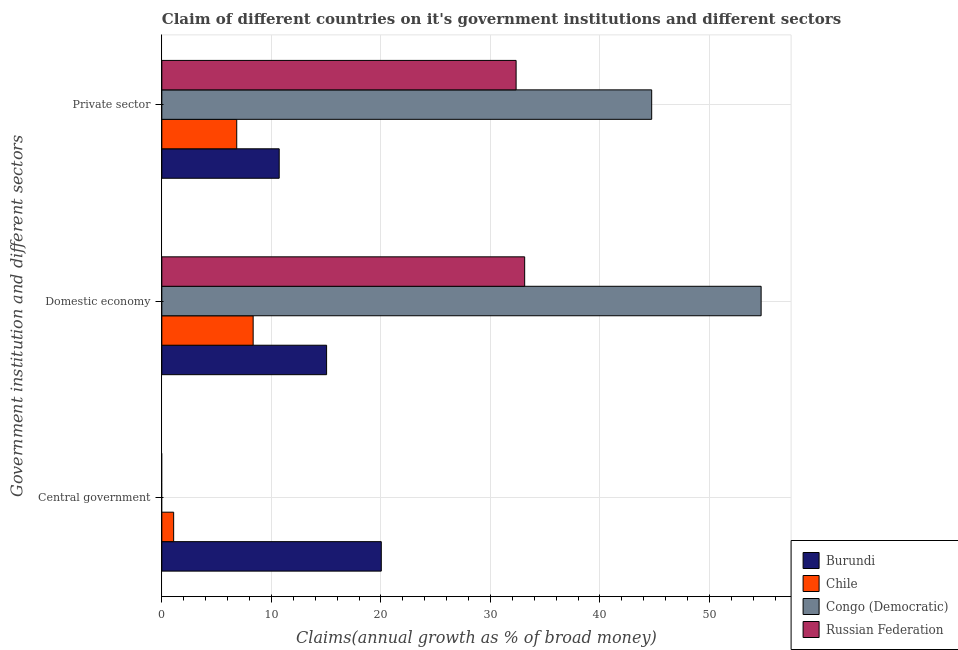Are the number of bars per tick equal to the number of legend labels?
Offer a very short reply. No. What is the label of the 2nd group of bars from the top?
Give a very brief answer. Domestic economy. What is the percentage of claim on the domestic economy in Congo (Democratic)?
Keep it short and to the point. 54.71. Across all countries, what is the maximum percentage of claim on the central government?
Your answer should be compact. 20.04. Across all countries, what is the minimum percentage of claim on the domestic economy?
Offer a very short reply. 8.34. In which country was the percentage of claim on the private sector maximum?
Provide a succinct answer. Congo (Democratic). What is the total percentage of claim on the domestic economy in the graph?
Your response must be concise. 111.22. What is the difference between the percentage of claim on the private sector in Congo (Democratic) and that in Russian Federation?
Your answer should be compact. 12.38. What is the difference between the percentage of claim on the central government in Chile and the percentage of claim on the domestic economy in Russian Federation?
Your response must be concise. -32.05. What is the average percentage of claim on the domestic economy per country?
Provide a short and direct response. 27.8. What is the difference between the percentage of claim on the private sector and percentage of claim on the domestic economy in Russian Federation?
Your answer should be very brief. -0.78. In how many countries, is the percentage of claim on the central government greater than 30 %?
Your response must be concise. 0. What is the ratio of the percentage of claim on the domestic economy in Russian Federation to that in Chile?
Your answer should be very brief. 3.97. Is the difference between the percentage of claim on the domestic economy in Burundi and Chile greater than the difference between the percentage of claim on the private sector in Burundi and Chile?
Your answer should be very brief. Yes. What is the difference between the highest and the second highest percentage of claim on the private sector?
Keep it short and to the point. 12.38. What is the difference between the highest and the lowest percentage of claim on the central government?
Offer a very short reply. 20.04. In how many countries, is the percentage of claim on the domestic economy greater than the average percentage of claim on the domestic economy taken over all countries?
Your answer should be very brief. 2. Is the sum of the percentage of claim on the private sector in Congo (Democratic) and Burundi greater than the maximum percentage of claim on the central government across all countries?
Make the answer very short. Yes. How many bars are there?
Your answer should be very brief. 10. Are all the bars in the graph horizontal?
Offer a very short reply. Yes. How many countries are there in the graph?
Provide a short and direct response. 4. Are the values on the major ticks of X-axis written in scientific E-notation?
Keep it short and to the point. No. How many legend labels are there?
Make the answer very short. 4. How are the legend labels stacked?
Your response must be concise. Vertical. What is the title of the graph?
Keep it short and to the point. Claim of different countries on it's government institutions and different sectors. What is the label or title of the X-axis?
Provide a short and direct response. Claims(annual growth as % of broad money). What is the label or title of the Y-axis?
Give a very brief answer. Government institution and different sectors. What is the Claims(annual growth as % of broad money) in Burundi in Central government?
Ensure brevity in your answer.  20.04. What is the Claims(annual growth as % of broad money) in Chile in Central government?
Your answer should be very brief. 1.08. What is the Claims(annual growth as % of broad money) of Congo (Democratic) in Central government?
Ensure brevity in your answer.  0. What is the Claims(annual growth as % of broad money) of Burundi in Domestic economy?
Offer a very short reply. 15.04. What is the Claims(annual growth as % of broad money) in Chile in Domestic economy?
Offer a very short reply. 8.34. What is the Claims(annual growth as % of broad money) of Congo (Democratic) in Domestic economy?
Make the answer very short. 54.71. What is the Claims(annual growth as % of broad money) of Russian Federation in Domestic economy?
Provide a succinct answer. 33.13. What is the Claims(annual growth as % of broad money) in Burundi in Private sector?
Provide a short and direct response. 10.72. What is the Claims(annual growth as % of broad money) of Chile in Private sector?
Your answer should be compact. 6.84. What is the Claims(annual growth as % of broad money) in Congo (Democratic) in Private sector?
Your answer should be very brief. 44.72. What is the Claims(annual growth as % of broad money) of Russian Federation in Private sector?
Your response must be concise. 32.34. Across all Government institution and different sectors, what is the maximum Claims(annual growth as % of broad money) in Burundi?
Give a very brief answer. 20.04. Across all Government institution and different sectors, what is the maximum Claims(annual growth as % of broad money) in Chile?
Make the answer very short. 8.34. Across all Government institution and different sectors, what is the maximum Claims(annual growth as % of broad money) in Congo (Democratic)?
Keep it short and to the point. 54.71. Across all Government institution and different sectors, what is the maximum Claims(annual growth as % of broad money) in Russian Federation?
Keep it short and to the point. 33.13. Across all Government institution and different sectors, what is the minimum Claims(annual growth as % of broad money) of Burundi?
Give a very brief answer. 10.72. Across all Government institution and different sectors, what is the minimum Claims(annual growth as % of broad money) of Chile?
Your answer should be very brief. 1.08. Across all Government institution and different sectors, what is the minimum Claims(annual growth as % of broad money) in Congo (Democratic)?
Offer a terse response. 0. What is the total Claims(annual growth as % of broad money) of Burundi in the graph?
Make the answer very short. 45.79. What is the total Claims(annual growth as % of broad money) of Chile in the graph?
Offer a terse response. 16.26. What is the total Claims(annual growth as % of broad money) of Congo (Democratic) in the graph?
Your response must be concise. 99.43. What is the total Claims(annual growth as % of broad money) in Russian Federation in the graph?
Ensure brevity in your answer.  65.47. What is the difference between the Claims(annual growth as % of broad money) in Burundi in Central government and that in Domestic economy?
Make the answer very short. 4.99. What is the difference between the Claims(annual growth as % of broad money) of Chile in Central government and that in Domestic economy?
Your answer should be very brief. -7.26. What is the difference between the Claims(annual growth as % of broad money) in Burundi in Central government and that in Private sector?
Make the answer very short. 9.32. What is the difference between the Claims(annual growth as % of broad money) of Chile in Central government and that in Private sector?
Provide a succinct answer. -5.76. What is the difference between the Claims(annual growth as % of broad money) of Burundi in Domestic economy and that in Private sector?
Offer a very short reply. 4.33. What is the difference between the Claims(annual growth as % of broad money) in Chile in Domestic economy and that in Private sector?
Your answer should be compact. 1.5. What is the difference between the Claims(annual growth as % of broad money) of Congo (Democratic) in Domestic economy and that in Private sector?
Your response must be concise. 9.99. What is the difference between the Claims(annual growth as % of broad money) in Russian Federation in Domestic economy and that in Private sector?
Keep it short and to the point. 0.78. What is the difference between the Claims(annual growth as % of broad money) of Burundi in Central government and the Claims(annual growth as % of broad money) of Chile in Domestic economy?
Your answer should be very brief. 11.7. What is the difference between the Claims(annual growth as % of broad money) of Burundi in Central government and the Claims(annual growth as % of broad money) of Congo (Democratic) in Domestic economy?
Ensure brevity in your answer.  -34.68. What is the difference between the Claims(annual growth as % of broad money) of Burundi in Central government and the Claims(annual growth as % of broad money) of Russian Federation in Domestic economy?
Your answer should be very brief. -13.09. What is the difference between the Claims(annual growth as % of broad money) in Chile in Central government and the Claims(annual growth as % of broad money) in Congo (Democratic) in Domestic economy?
Give a very brief answer. -53.63. What is the difference between the Claims(annual growth as % of broad money) of Chile in Central government and the Claims(annual growth as % of broad money) of Russian Federation in Domestic economy?
Keep it short and to the point. -32.05. What is the difference between the Claims(annual growth as % of broad money) of Burundi in Central government and the Claims(annual growth as % of broad money) of Chile in Private sector?
Provide a short and direct response. 13.2. What is the difference between the Claims(annual growth as % of broad money) of Burundi in Central government and the Claims(annual growth as % of broad money) of Congo (Democratic) in Private sector?
Provide a succinct answer. -24.69. What is the difference between the Claims(annual growth as % of broad money) in Burundi in Central government and the Claims(annual growth as % of broad money) in Russian Federation in Private sector?
Your answer should be very brief. -12.31. What is the difference between the Claims(annual growth as % of broad money) in Chile in Central government and the Claims(annual growth as % of broad money) in Congo (Democratic) in Private sector?
Make the answer very short. -43.64. What is the difference between the Claims(annual growth as % of broad money) of Chile in Central government and the Claims(annual growth as % of broad money) of Russian Federation in Private sector?
Provide a short and direct response. -31.26. What is the difference between the Claims(annual growth as % of broad money) of Burundi in Domestic economy and the Claims(annual growth as % of broad money) of Chile in Private sector?
Your response must be concise. 8.2. What is the difference between the Claims(annual growth as % of broad money) in Burundi in Domestic economy and the Claims(annual growth as % of broad money) in Congo (Democratic) in Private sector?
Offer a terse response. -29.68. What is the difference between the Claims(annual growth as % of broad money) of Burundi in Domestic economy and the Claims(annual growth as % of broad money) of Russian Federation in Private sector?
Keep it short and to the point. -17.3. What is the difference between the Claims(annual growth as % of broad money) in Chile in Domestic economy and the Claims(annual growth as % of broad money) in Congo (Democratic) in Private sector?
Your answer should be very brief. -36.38. What is the difference between the Claims(annual growth as % of broad money) in Chile in Domestic economy and the Claims(annual growth as % of broad money) in Russian Federation in Private sector?
Give a very brief answer. -24.01. What is the difference between the Claims(annual growth as % of broad money) of Congo (Democratic) in Domestic economy and the Claims(annual growth as % of broad money) of Russian Federation in Private sector?
Your response must be concise. 22.37. What is the average Claims(annual growth as % of broad money) of Burundi per Government institution and different sectors?
Your answer should be compact. 15.26. What is the average Claims(annual growth as % of broad money) of Chile per Government institution and different sectors?
Keep it short and to the point. 5.42. What is the average Claims(annual growth as % of broad money) in Congo (Democratic) per Government institution and different sectors?
Offer a terse response. 33.14. What is the average Claims(annual growth as % of broad money) of Russian Federation per Government institution and different sectors?
Ensure brevity in your answer.  21.82. What is the difference between the Claims(annual growth as % of broad money) of Burundi and Claims(annual growth as % of broad money) of Chile in Central government?
Offer a terse response. 18.96. What is the difference between the Claims(annual growth as % of broad money) in Burundi and Claims(annual growth as % of broad money) in Chile in Domestic economy?
Offer a terse response. 6.7. What is the difference between the Claims(annual growth as % of broad money) of Burundi and Claims(annual growth as % of broad money) of Congo (Democratic) in Domestic economy?
Provide a short and direct response. -39.67. What is the difference between the Claims(annual growth as % of broad money) in Burundi and Claims(annual growth as % of broad money) in Russian Federation in Domestic economy?
Offer a very short reply. -18.08. What is the difference between the Claims(annual growth as % of broad money) in Chile and Claims(annual growth as % of broad money) in Congo (Democratic) in Domestic economy?
Give a very brief answer. -46.37. What is the difference between the Claims(annual growth as % of broad money) in Chile and Claims(annual growth as % of broad money) in Russian Federation in Domestic economy?
Keep it short and to the point. -24.79. What is the difference between the Claims(annual growth as % of broad money) in Congo (Democratic) and Claims(annual growth as % of broad money) in Russian Federation in Domestic economy?
Keep it short and to the point. 21.59. What is the difference between the Claims(annual growth as % of broad money) in Burundi and Claims(annual growth as % of broad money) in Chile in Private sector?
Offer a terse response. 3.88. What is the difference between the Claims(annual growth as % of broad money) of Burundi and Claims(annual growth as % of broad money) of Congo (Democratic) in Private sector?
Make the answer very short. -34.01. What is the difference between the Claims(annual growth as % of broad money) in Burundi and Claims(annual growth as % of broad money) in Russian Federation in Private sector?
Your answer should be compact. -21.63. What is the difference between the Claims(annual growth as % of broad money) of Chile and Claims(annual growth as % of broad money) of Congo (Democratic) in Private sector?
Offer a terse response. -37.88. What is the difference between the Claims(annual growth as % of broad money) of Chile and Claims(annual growth as % of broad money) of Russian Federation in Private sector?
Provide a short and direct response. -25.51. What is the difference between the Claims(annual growth as % of broad money) of Congo (Democratic) and Claims(annual growth as % of broad money) of Russian Federation in Private sector?
Make the answer very short. 12.38. What is the ratio of the Claims(annual growth as % of broad money) in Burundi in Central government to that in Domestic economy?
Ensure brevity in your answer.  1.33. What is the ratio of the Claims(annual growth as % of broad money) in Chile in Central government to that in Domestic economy?
Provide a short and direct response. 0.13. What is the ratio of the Claims(annual growth as % of broad money) of Burundi in Central government to that in Private sector?
Provide a succinct answer. 1.87. What is the ratio of the Claims(annual growth as % of broad money) of Chile in Central government to that in Private sector?
Offer a terse response. 0.16. What is the ratio of the Claims(annual growth as % of broad money) of Burundi in Domestic economy to that in Private sector?
Keep it short and to the point. 1.4. What is the ratio of the Claims(annual growth as % of broad money) of Chile in Domestic economy to that in Private sector?
Make the answer very short. 1.22. What is the ratio of the Claims(annual growth as % of broad money) of Congo (Democratic) in Domestic economy to that in Private sector?
Provide a succinct answer. 1.22. What is the ratio of the Claims(annual growth as % of broad money) of Russian Federation in Domestic economy to that in Private sector?
Your answer should be very brief. 1.02. What is the difference between the highest and the second highest Claims(annual growth as % of broad money) of Burundi?
Your answer should be very brief. 4.99. What is the difference between the highest and the second highest Claims(annual growth as % of broad money) of Chile?
Offer a very short reply. 1.5. What is the difference between the highest and the lowest Claims(annual growth as % of broad money) in Burundi?
Ensure brevity in your answer.  9.32. What is the difference between the highest and the lowest Claims(annual growth as % of broad money) of Chile?
Offer a terse response. 7.26. What is the difference between the highest and the lowest Claims(annual growth as % of broad money) of Congo (Democratic)?
Give a very brief answer. 54.71. What is the difference between the highest and the lowest Claims(annual growth as % of broad money) in Russian Federation?
Ensure brevity in your answer.  33.13. 